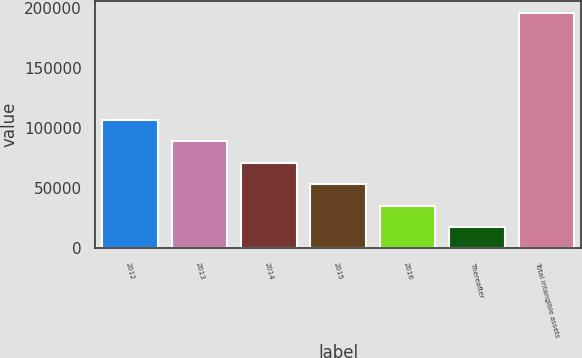Convert chart to OTSL. <chart><loc_0><loc_0><loc_500><loc_500><bar_chart><fcel>2012<fcel>2013<fcel>2014<fcel>2015<fcel>2016<fcel>Thereafter<fcel>Total intangible assets<nl><fcel>106835<fcel>88989.4<fcel>71143.8<fcel>53298.2<fcel>35452.6<fcel>17607<fcel>196063<nl></chart> 